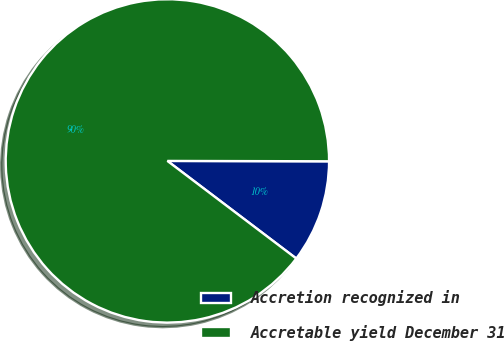Convert chart. <chart><loc_0><loc_0><loc_500><loc_500><pie_chart><fcel>Accretion recognized in<fcel>Accretable yield December 31<nl><fcel>10.28%<fcel>89.72%<nl></chart> 